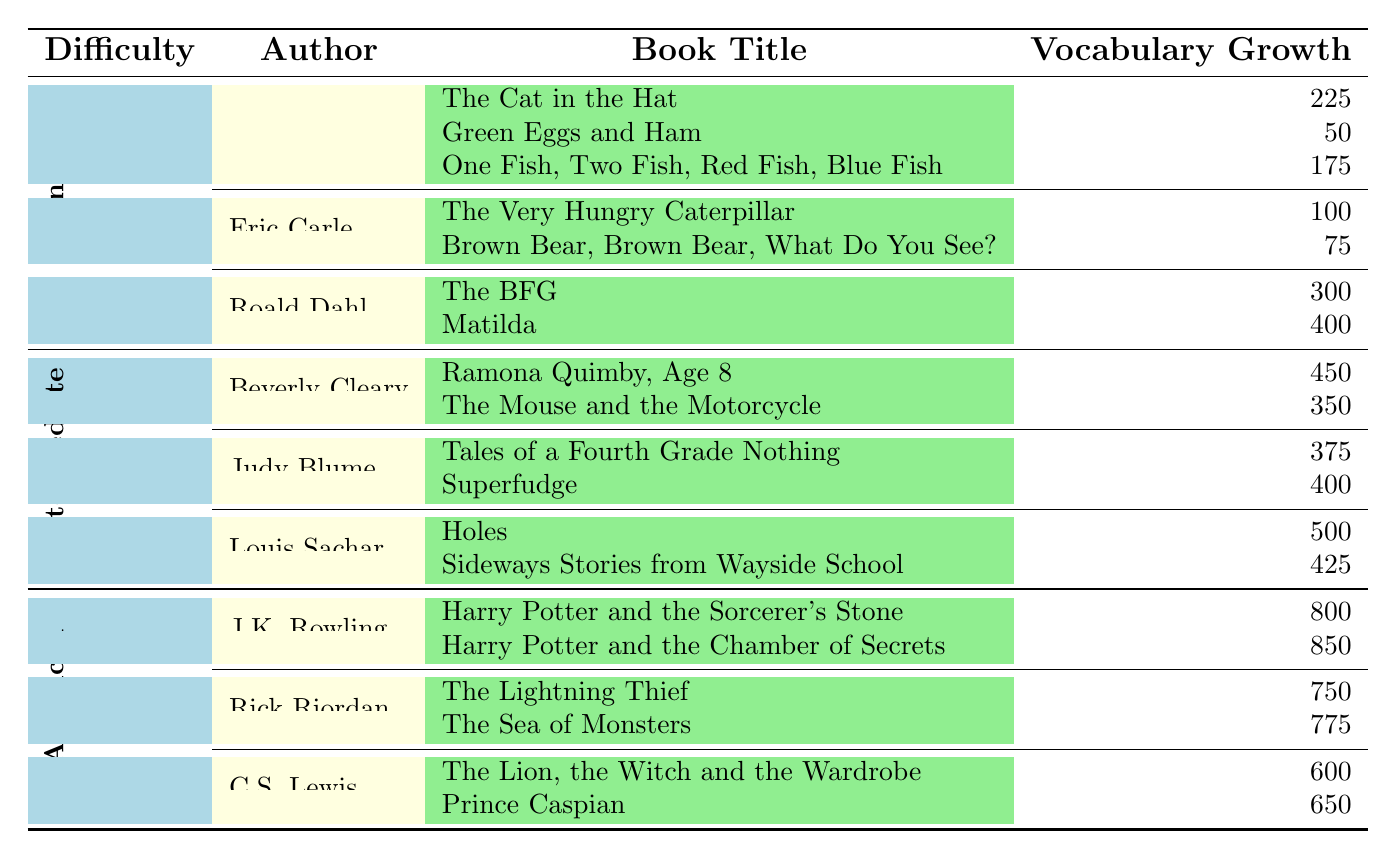What's the total vocabulary growth for all the books at the Beginner Level? To find the total vocabulary growth for Beginner Level, we sum the vocabulary counts for all the books listed: 225 + 50 + 175 + 100 + 75 + 300 + 400 = 1325.
Answer: 1325 Which author has the highest vocabulary growth in the Intermediate Level? In the Intermediate Level, by comparing the maximum vocabulary counts: Beverly Cleary's highest is 450, Judy Blume's highest is 400, and Louis Sachar's highest is 500. Louis Sachar has the highest with Holes at 500.
Answer: Louis Sachar Is there a Roald Dahl book that has a higher vocabulary growth than the Eric Carle books? Roald Dahl's highest vocabulary growth is Matilda at 400. Eric Carle's highest is The Very Hungry Caterpillar at 100. Since 400 > 100, the statement is true.
Answer: Yes What is the average vocabulary growth for the books at the Advanced Level? To calculate the average, we add up all the vocabulary counts at the Advanced Level: 800 + 850 + 750 + 775 + 600 + 650 = 4275. There are 6 books, so the average is 4275 / 6 = 712.5.
Answer: 712.5 How many more vocabulary words does the book "Harry Potter and the Chamber of Secrets" have compared to "Matilda"? "Harry Potter and the Chamber of Secrets" has 850 words, and "Matilda" has 400 words. The difference is 850 - 400 = 450.
Answer: 450 Which level contains the book with the lowest vocabulary growth? The lowest vocabulary growth is from "Green Eggs and Ham" by Dr. Seuss in the Beginner Level with 50 words. Therefore, the Lowest vocabulary growth book is in the Beginner Level.
Answer: Beginner Level What percentage of total vocabulary growth does the J.K. Rowling books contribute compared to the Advanced Level total? Total vocabulary growth for Advanced Level is 800 + 850 + 750 + 775 + 600 + 650 = 4275. The contribution by J.K. Rowling is 800 + 850 = 1650. To find the percentage: (1650 / 4275) * 100 = 38.6%.
Answer: 38.6% Which category has the most books listed, and how many are there? By counting the entries, Beginner Level has 7 books (3 from Dr. Seuss, 2 from Eric Carle, 2 from Roald Dahl). Intermediate Level has 6 (2 from Beverly Cleary, 2 from Judy Blume, 2 from Louis Sachar). Advanced Level also has 6. Therefore, Beginner Level has the most books with 7.
Answer: Beginner Level What is the total vocabulary growth for the author Rick Riordan? Rick Riordan has two books: "The Lightning Thief" has 750 and "The Sea of Monsters" has 775. Total vocabulary growth is 750 + 775 = 1525.
Answer: 1525 Is the vocabulary growth in "One Fish, Two Fish, Red Fish, Blue Fish" greater than the average of Eric Carle books? "One Fish, Two Fish, Red Fish, Blue Fish" has 175, while the average of Eric Carle books is (100 + 75) / 2 = 87.5. Since 175 > 87.5, the statement is true.
Answer: Yes 